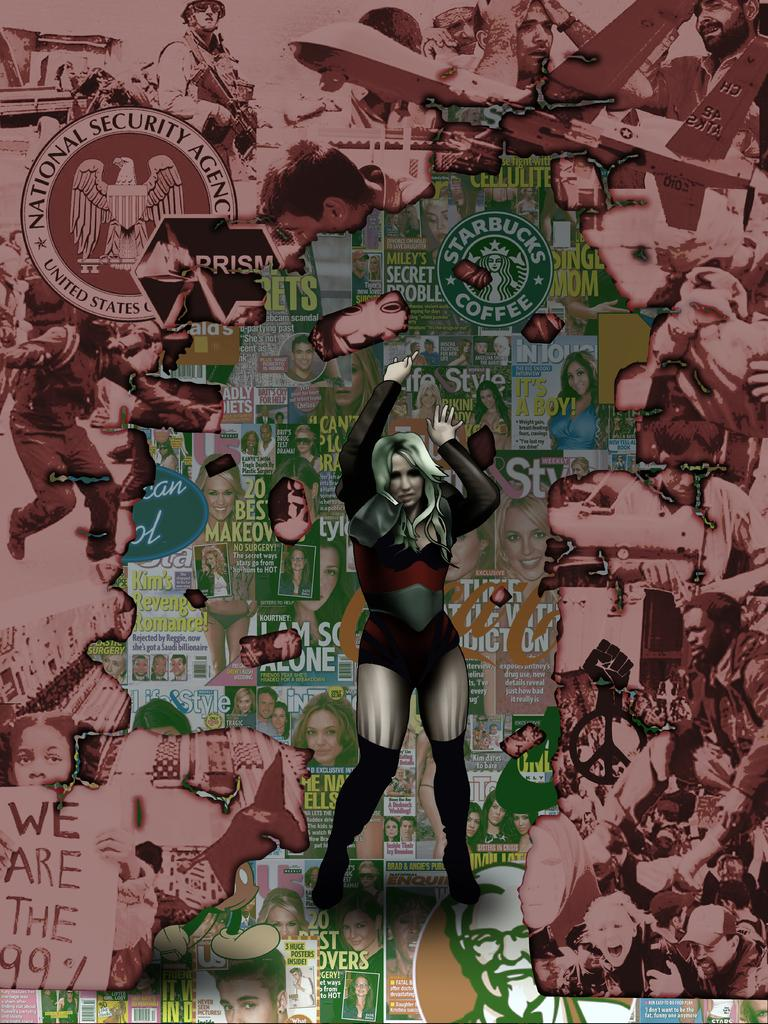<image>
Offer a succinct explanation of the picture presented. A woman stands in front of covers of different tabloids, a Starbucks coffee logo, and the seal for the National Security Agency. 